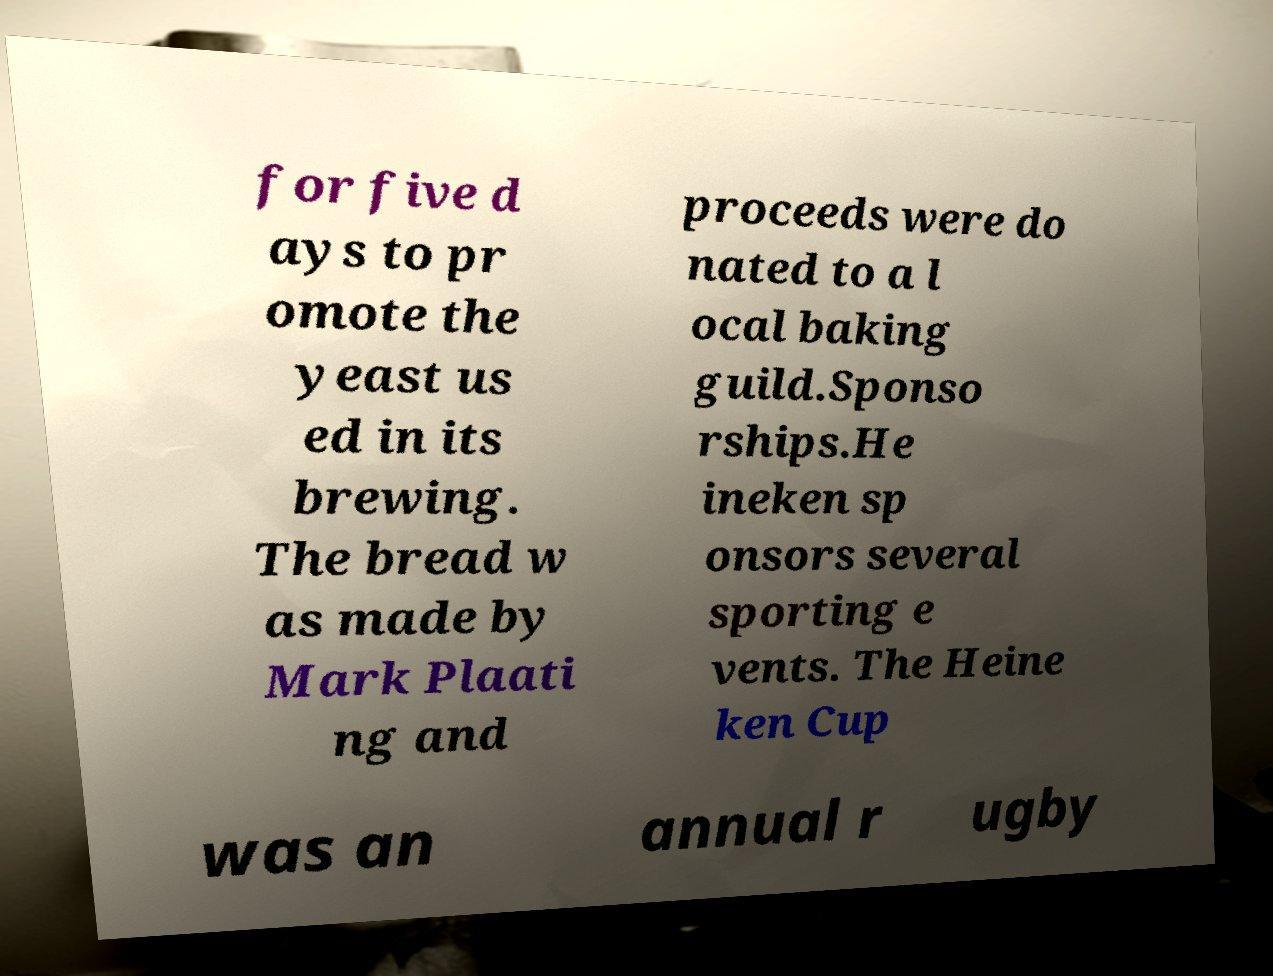Please identify and transcribe the text found in this image. for five d ays to pr omote the yeast us ed in its brewing. The bread w as made by Mark Plaati ng and proceeds were do nated to a l ocal baking guild.Sponso rships.He ineken sp onsors several sporting e vents. The Heine ken Cup was an annual r ugby 